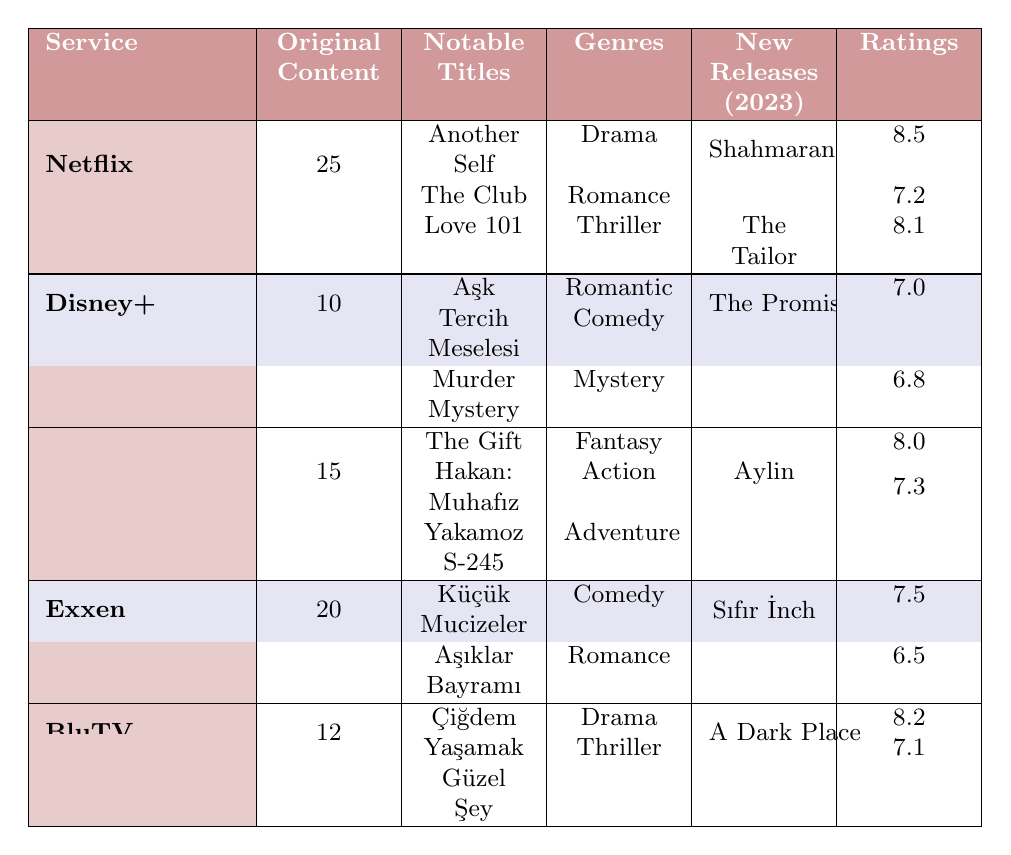What is the total number of original content offered by Netflix? According to the table, Netflix has an original content count of 25.
Answer: 25 Which streaming service has the most original content? Comparing the original content counts, Netflix has 25, Exxen has 20, Amazon Prime Video has 15, BluTV has 12, and Disney+ has 10. Therefore, Netflix has the most original content.
Answer: Netflix How many genres does Amazon Prime Video cover? Amazon Prime Video has three notable genres listed: Fantasy, Action, and Adventure.
Answer: 3 What notable title is associated with Disney+? Disney+ has two notable titles listed: Aşk Tercih Meselesi and Murder Mystery.
Answer: Aşk Tercih Meselesi What is the highest viewership rating for Exxen's original content? The viewership ratings for Exxen’s notable titles are 7.5 and 6.5, so the highest rating is 7.5.
Answer: 7.5 Is the viewership rating for "Another Self" higher than that of "Hakan: Muhafız"? The viewership rating for "Another Self" is 8.5, and for "Hakan: Muhafız" it is 7.3. Since 8.5 is greater than 7.3, the answer is yes.
Answer: Yes What is the average viewership rating of BluTV's notable titles? BluTV has ratings of 8.2 and 7.1. Adding them gives 15.3, and dividing by 2 gives an average rating of 7.65.
Answer: 7.65 How does the number of new releases in 2023 for Netflix compare to Exxen? Netflix has 2 new releases (Shahmaran and The Tailor), while Exxen has 1 new release (Sıfır İnch). Since 2 is greater than 1, Netflix has more new releases.
Answer: Netflix has more Which streaming service has the lowest viewership rating among its notable titles? By looking at the viewership ratings, Disney+ has the lowest at 6.8 (for Murder Mystery).
Answer: Disney+ If we combine the original content counts of Amazon Prime Video and BluTV, what is the total? Amazon Prime Video has 15 original contents and BluTV has 12. Adding them gives a total of 27.
Answer: 27 